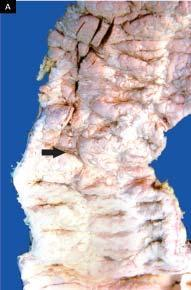what contain necrotic tissue?
Answer the question using a single word or phrase. Broad base 